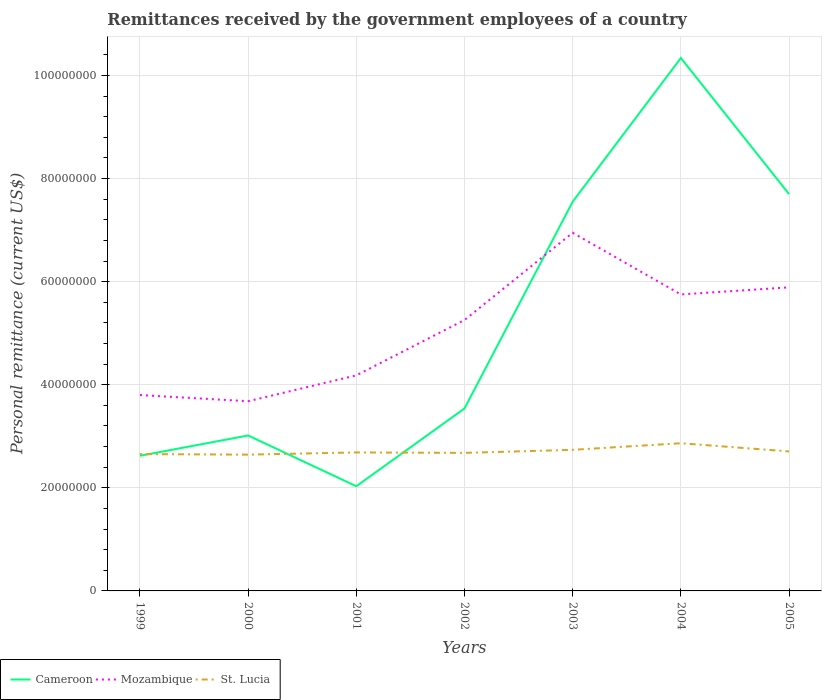How many different coloured lines are there?
Your response must be concise. 3. Across all years, what is the maximum remittances received by the government employees in St. Lucia?
Your answer should be very brief. 2.64e+07. In which year was the remittances received by the government employees in Mozambique maximum?
Your response must be concise. 2000. What is the total remittances received by the government employees in St. Lucia in the graph?
Your response must be concise. 1.04e+05. What is the difference between the highest and the second highest remittances received by the government employees in Cameroon?
Provide a succinct answer. 8.31e+07. Is the remittances received by the government employees in St. Lucia strictly greater than the remittances received by the government employees in Mozambique over the years?
Provide a short and direct response. Yes. How many lines are there?
Provide a short and direct response. 3. How many years are there in the graph?
Ensure brevity in your answer.  7. What is the difference between two consecutive major ticks on the Y-axis?
Provide a succinct answer. 2.00e+07. Are the values on the major ticks of Y-axis written in scientific E-notation?
Provide a short and direct response. No. How are the legend labels stacked?
Keep it short and to the point. Horizontal. What is the title of the graph?
Your answer should be compact. Remittances received by the government employees of a country. What is the label or title of the X-axis?
Make the answer very short. Years. What is the label or title of the Y-axis?
Provide a succinct answer. Personal remittance (current US$). What is the Personal remittance (current US$) of Cameroon in 1999?
Provide a succinct answer. 2.62e+07. What is the Personal remittance (current US$) of Mozambique in 1999?
Provide a short and direct response. 3.80e+07. What is the Personal remittance (current US$) of St. Lucia in 1999?
Provide a short and direct response. 2.65e+07. What is the Personal remittance (current US$) in Cameroon in 2000?
Provide a succinct answer. 3.02e+07. What is the Personal remittance (current US$) of Mozambique in 2000?
Your response must be concise. 3.68e+07. What is the Personal remittance (current US$) of St. Lucia in 2000?
Offer a terse response. 2.64e+07. What is the Personal remittance (current US$) of Cameroon in 2001?
Ensure brevity in your answer.  2.03e+07. What is the Personal remittance (current US$) of Mozambique in 2001?
Your answer should be very brief. 4.18e+07. What is the Personal remittance (current US$) in St. Lucia in 2001?
Keep it short and to the point. 2.69e+07. What is the Personal remittance (current US$) in Cameroon in 2002?
Your answer should be compact. 3.54e+07. What is the Personal remittance (current US$) of Mozambique in 2002?
Offer a terse response. 5.26e+07. What is the Personal remittance (current US$) in St. Lucia in 2002?
Your answer should be very brief. 2.68e+07. What is the Personal remittance (current US$) of Cameroon in 2003?
Give a very brief answer. 7.55e+07. What is the Personal remittance (current US$) of Mozambique in 2003?
Keep it short and to the point. 6.95e+07. What is the Personal remittance (current US$) in St. Lucia in 2003?
Keep it short and to the point. 2.74e+07. What is the Personal remittance (current US$) in Cameroon in 2004?
Offer a very short reply. 1.03e+08. What is the Personal remittance (current US$) in Mozambique in 2004?
Provide a short and direct response. 5.75e+07. What is the Personal remittance (current US$) of St. Lucia in 2004?
Your response must be concise. 2.87e+07. What is the Personal remittance (current US$) of Cameroon in 2005?
Keep it short and to the point. 7.70e+07. What is the Personal remittance (current US$) of Mozambique in 2005?
Provide a succinct answer. 5.89e+07. What is the Personal remittance (current US$) in St. Lucia in 2005?
Make the answer very short. 2.71e+07. Across all years, what is the maximum Personal remittance (current US$) in Cameroon?
Provide a short and direct response. 1.03e+08. Across all years, what is the maximum Personal remittance (current US$) of Mozambique?
Your response must be concise. 6.95e+07. Across all years, what is the maximum Personal remittance (current US$) of St. Lucia?
Your answer should be compact. 2.87e+07. Across all years, what is the minimum Personal remittance (current US$) of Cameroon?
Your response must be concise. 2.03e+07. Across all years, what is the minimum Personal remittance (current US$) of Mozambique?
Make the answer very short. 3.68e+07. Across all years, what is the minimum Personal remittance (current US$) in St. Lucia?
Provide a succinct answer. 2.64e+07. What is the total Personal remittance (current US$) in Cameroon in the graph?
Provide a succinct answer. 3.68e+08. What is the total Personal remittance (current US$) of Mozambique in the graph?
Provide a short and direct response. 3.55e+08. What is the total Personal remittance (current US$) of St. Lucia in the graph?
Keep it short and to the point. 1.90e+08. What is the difference between the Personal remittance (current US$) of Cameroon in 1999 and that in 2000?
Provide a short and direct response. -3.94e+06. What is the difference between the Personal remittance (current US$) of Mozambique in 1999 and that in 2000?
Your response must be concise. 1.20e+06. What is the difference between the Personal remittance (current US$) of St. Lucia in 1999 and that in 2000?
Give a very brief answer. 1.04e+05. What is the difference between the Personal remittance (current US$) in Cameroon in 1999 and that in 2001?
Offer a very short reply. 5.91e+06. What is the difference between the Personal remittance (current US$) of Mozambique in 1999 and that in 2001?
Provide a short and direct response. -3.82e+06. What is the difference between the Personal remittance (current US$) of St. Lucia in 1999 and that in 2001?
Provide a succinct answer. -3.23e+05. What is the difference between the Personal remittance (current US$) in Cameroon in 1999 and that in 2002?
Keep it short and to the point. -9.18e+06. What is the difference between the Personal remittance (current US$) of Mozambique in 1999 and that in 2002?
Ensure brevity in your answer.  -1.46e+07. What is the difference between the Personal remittance (current US$) of St. Lucia in 1999 and that in 2002?
Your answer should be compact. -2.34e+05. What is the difference between the Personal remittance (current US$) in Cameroon in 1999 and that in 2003?
Give a very brief answer. -4.93e+07. What is the difference between the Personal remittance (current US$) of Mozambique in 1999 and that in 2003?
Your response must be concise. -3.15e+07. What is the difference between the Personal remittance (current US$) of St. Lucia in 1999 and that in 2003?
Keep it short and to the point. -8.27e+05. What is the difference between the Personal remittance (current US$) in Cameroon in 1999 and that in 2004?
Keep it short and to the point. -7.72e+07. What is the difference between the Personal remittance (current US$) of Mozambique in 1999 and that in 2004?
Ensure brevity in your answer.  -1.95e+07. What is the difference between the Personal remittance (current US$) of St. Lucia in 1999 and that in 2004?
Your answer should be very brief. -2.11e+06. What is the difference between the Personal remittance (current US$) of Cameroon in 1999 and that in 2005?
Provide a succinct answer. -5.08e+07. What is the difference between the Personal remittance (current US$) of Mozambique in 1999 and that in 2005?
Your response must be concise. -2.09e+07. What is the difference between the Personal remittance (current US$) in St. Lucia in 1999 and that in 2005?
Your answer should be compact. -5.19e+05. What is the difference between the Personal remittance (current US$) of Cameroon in 2000 and that in 2001?
Your response must be concise. 9.85e+06. What is the difference between the Personal remittance (current US$) of Mozambique in 2000 and that in 2001?
Provide a succinct answer. -5.02e+06. What is the difference between the Personal remittance (current US$) of St. Lucia in 2000 and that in 2001?
Your response must be concise. -4.27e+05. What is the difference between the Personal remittance (current US$) of Cameroon in 2000 and that in 2002?
Ensure brevity in your answer.  -5.24e+06. What is the difference between the Personal remittance (current US$) in Mozambique in 2000 and that in 2002?
Give a very brief answer. -1.58e+07. What is the difference between the Personal remittance (current US$) in St. Lucia in 2000 and that in 2002?
Provide a succinct answer. -3.38e+05. What is the difference between the Personal remittance (current US$) in Cameroon in 2000 and that in 2003?
Ensure brevity in your answer.  -4.54e+07. What is the difference between the Personal remittance (current US$) of Mozambique in 2000 and that in 2003?
Your response must be concise. -3.27e+07. What is the difference between the Personal remittance (current US$) of St. Lucia in 2000 and that in 2003?
Give a very brief answer. -9.31e+05. What is the difference between the Personal remittance (current US$) of Cameroon in 2000 and that in 2004?
Your response must be concise. -7.32e+07. What is the difference between the Personal remittance (current US$) of Mozambique in 2000 and that in 2004?
Your response must be concise. -2.07e+07. What is the difference between the Personal remittance (current US$) of St. Lucia in 2000 and that in 2004?
Your response must be concise. -2.21e+06. What is the difference between the Personal remittance (current US$) of Cameroon in 2000 and that in 2005?
Provide a short and direct response. -4.68e+07. What is the difference between the Personal remittance (current US$) of Mozambique in 2000 and that in 2005?
Ensure brevity in your answer.  -2.21e+07. What is the difference between the Personal remittance (current US$) of St. Lucia in 2000 and that in 2005?
Your response must be concise. -6.23e+05. What is the difference between the Personal remittance (current US$) in Cameroon in 2001 and that in 2002?
Offer a very short reply. -1.51e+07. What is the difference between the Personal remittance (current US$) in Mozambique in 2001 and that in 2002?
Offer a terse response. -1.07e+07. What is the difference between the Personal remittance (current US$) of St. Lucia in 2001 and that in 2002?
Make the answer very short. 8.88e+04. What is the difference between the Personal remittance (current US$) of Cameroon in 2001 and that in 2003?
Provide a succinct answer. -5.52e+07. What is the difference between the Personal remittance (current US$) in Mozambique in 2001 and that in 2003?
Make the answer very short. -2.77e+07. What is the difference between the Personal remittance (current US$) of St. Lucia in 2001 and that in 2003?
Give a very brief answer. -5.04e+05. What is the difference between the Personal remittance (current US$) in Cameroon in 2001 and that in 2004?
Your answer should be compact. -8.31e+07. What is the difference between the Personal remittance (current US$) in Mozambique in 2001 and that in 2004?
Your answer should be very brief. -1.57e+07. What is the difference between the Personal remittance (current US$) of St. Lucia in 2001 and that in 2004?
Your response must be concise. -1.78e+06. What is the difference between the Personal remittance (current US$) in Cameroon in 2001 and that in 2005?
Your response must be concise. -5.67e+07. What is the difference between the Personal remittance (current US$) in Mozambique in 2001 and that in 2005?
Ensure brevity in your answer.  -1.71e+07. What is the difference between the Personal remittance (current US$) of St. Lucia in 2001 and that in 2005?
Offer a terse response. -1.96e+05. What is the difference between the Personal remittance (current US$) in Cameroon in 2002 and that in 2003?
Ensure brevity in your answer.  -4.01e+07. What is the difference between the Personal remittance (current US$) in Mozambique in 2002 and that in 2003?
Provide a succinct answer. -1.69e+07. What is the difference between the Personal remittance (current US$) in St. Lucia in 2002 and that in 2003?
Keep it short and to the point. -5.93e+05. What is the difference between the Personal remittance (current US$) in Cameroon in 2002 and that in 2004?
Ensure brevity in your answer.  -6.80e+07. What is the difference between the Personal remittance (current US$) in Mozambique in 2002 and that in 2004?
Your response must be concise. -4.96e+06. What is the difference between the Personal remittance (current US$) of St. Lucia in 2002 and that in 2004?
Your answer should be very brief. -1.87e+06. What is the difference between the Personal remittance (current US$) of Cameroon in 2002 and that in 2005?
Provide a short and direct response. -4.16e+07. What is the difference between the Personal remittance (current US$) in Mozambique in 2002 and that in 2005?
Your answer should be very brief. -6.34e+06. What is the difference between the Personal remittance (current US$) of St. Lucia in 2002 and that in 2005?
Offer a very short reply. -2.85e+05. What is the difference between the Personal remittance (current US$) in Cameroon in 2003 and that in 2004?
Make the answer very short. -2.79e+07. What is the difference between the Personal remittance (current US$) of Mozambique in 2003 and that in 2004?
Your response must be concise. 1.20e+07. What is the difference between the Personal remittance (current US$) in St. Lucia in 2003 and that in 2004?
Your response must be concise. -1.28e+06. What is the difference between the Personal remittance (current US$) in Cameroon in 2003 and that in 2005?
Keep it short and to the point. -1.48e+06. What is the difference between the Personal remittance (current US$) in Mozambique in 2003 and that in 2005?
Offer a terse response. 1.06e+07. What is the difference between the Personal remittance (current US$) of St. Lucia in 2003 and that in 2005?
Provide a succinct answer. 3.08e+05. What is the difference between the Personal remittance (current US$) of Cameroon in 2004 and that in 2005?
Your answer should be compact. 2.64e+07. What is the difference between the Personal remittance (current US$) of Mozambique in 2004 and that in 2005?
Provide a succinct answer. -1.37e+06. What is the difference between the Personal remittance (current US$) in St. Lucia in 2004 and that in 2005?
Provide a short and direct response. 1.59e+06. What is the difference between the Personal remittance (current US$) in Cameroon in 1999 and the Personal remittance (current US$) in Mozambique in 2000?
Your answer should be very brief. -1.06e+07. What is the difference between the Personal remittance (current US$) of Cameroon in 1999 and the Personal remittance (current US$) of St. Lucia in 2000?
Offer a very short reply. -2.19e+05. What is the difference between the Personal remittance (current US$) of Mozambique in 1999 and the Personal remittance (current US$) of St. Lucia in 2000?
Your answer should be compact. 1.16e+07. What is the difference between the Personal remittance (current US$) of Cameroon in 1999 and the Personal remittance (current US$) of Mozambique in 2001?
Provide a succinct answer. -1.56e+07. What is the difference between the Personal remittance (current US$) of Cameroon in 1999 and the Personal remittance (current US$) of St. Lucia in 2001?
Offer a terse response. -6.46e+05. What is the difference between the Personal remittance (current US$) in Mozambique in 1999 and the Personal remittance (current US$) in St. Lucia in 2001?
Keep it short and to the point. 1.11e+07. What is the difference between the Personal remittance (current US$) of Cameroon in 1999 and the Personal remittance (current US$) of Mozambique in 2002?
Offer a terse response. -2.63e+07. What is the difference between the Personal remittance (current US$) in Cameroon in 1999 and the Personal remittance (current US$) in St. Lucia in 2002?
Offer a very short reply. -5.57e+05. What is the difference between the Personal remittance (current US$) in Mozambique in 1999 and the Personal remittance (current US$) in St. Lucia in 2002?
Your response must be concise. 1.12e+07. What is the difference between the Personal remittance (current US$) in Cameroon in 1999 and the Personal remittance (current US$) in Mozambique in 2003?
Your answer should be compact. -4.33e+07. What is the difference between the Personal remittance (current US$) in Cameroon in 1999 and the Personal remittance (current US$) in St. Lucia in 2003?
Provide a short and direct response. -1.15e+06. What is the difference between the Personal remittance (current US$) of Mozambique in 1999 and the Personal remittance (current US$) of St. Lucia in 2003?
Offer a very short reply. 1.06e+07. What is the difference between the Personal remittance (current US$) of Cameroon in 1999 and the Personal remittance (current US$) of Mozambique in 2004?
Make the answer very short. -3.13e+07. What is the difference between the Personal remittance (current US$) of Cameroon in 1999 and the Personal remittance (current US$) of St. Lucia in 2004?
Provide a short and direct response. -2.43e+06. What is the difference between the Personal remittance (current US$) of Mozambique in 1999 and the Personal remittance (current US$) of St. Lucia in 2004?
Your answer should be compact. 9.35e+06. What is the difference between the Personal remittance (current US$) of Cameroon in 1999 and the Personal remittance (current US$) of Mozambique in 2005?
Give a very brief answer. -3.27e+07. What is the difference between the Personal remittance (current US$) in Cameroon in 1999 and the Personal remittance (current US$) in St. Lucia in 2005?
Make the answer very short. -8.42e+05. What is the difference between the Personal remittance (current US$) of Mozambique in 1999 and the Personal remittance (current US$) of St. Lucia in 2005?
Give a very brief answer. 1.09e+07. What is the difference between the Personal remittance (current US$) of Cameroon in 2000 and the Personal remittance (current US$) of Mozambique in 2001?
Make the answer very short. -1.17e+07. What is the difference between the Personal remittance (current US$) in Cameroon in 2000 and the Personal remittance (current US$) in St. Lucia in 2001?
Your answer should be compact. 3.29e+06. What is the difference between the Personal remittance (current US$) of Mozambique in 2000 and the Personal remittance (current US$) of St. Lucia in 2001?
Give a very brief answer. 9.93e+06. What is the difference between the Personal remittance (current US$) of Cameroon in 2000 and the Personal remittance (current US$) of Mozambique in 2002?
Provide a succinct answer. -2.24e+07. What is the difference between the Personal remittance (current US$) in Cameroon in 2000 and the Personal remittance (current US$) in St. Lucia in 2002?
Offer a terse response. 3.38e+06. What is the difference between the Personal remittance (current US$) of Mozambique in 2000 and the Personal remittance (current US$) of St. Lucia in 2002?
Provide a short and direct response. 1.00e+07. What is the difference between the Personal remittance (current US$) of Cameroon in 2000 and the Personal remittance (current US$) of Mozambique in 2003?
Provide a short and direct response. -3.93e+07. What is the difference between the Personal remittance (current US$) in Cameroon in 2000 and the Personal remittance (current US$) in St. Lucia in 2003?
Give a very brief answer. 2.79e+06. What is the difference between the Personal remittance (current US$) of Mozambique in 2000 and the Personal remittance (current US$) of St. Lucia in 2003?
Your answer should be very brief. 9.43e+06. What is the difference between the Personal remittance (current US$) of Cameroon in 2000 and the Personal remittance (current US$) of Mozambique in 2004?
Your response must be concise. -2.74e+07. What is the difference between the Personal remittance (current US$) in Cameroon in 2000 and the Personal remittance (current US$) in St. Lucia in 2004?
Keep it short and to the point. 1.51e+06. What is the difference between the Personal remittance (current US$) in Mozambique in 2000 and the Personal remittance (current US$) in St. Lucia in 2004?
Offer a very short reply. 8.15e+06. What is the difference between the Personal remittance (current US$) of Cameroon in 2000 and the Personal remittance (current US$) of Mozambique in 2005?
Offer a terse response. -2.87e+07. What is the difference between the Personal remittance (current US$) in Cameroon in 2000 and the Personal remittance (current US$) in St. Lucia in 2005?
Your answer should be compact. 3.10e+06. What is the difference between the Personal remittance (current US$) in Mozambique in 2000 and the Personal remittance (current US$) in St. Lucia in 2005?
Offer a very short reply. 9.74e+06. What is the difference between the Personal remittance (current US$) of Cameroon in 2001 and the Personal remittance (current US$) of Mozambique in 2002?
Your answer should be compact. -3.22e+07. What is the difference between the Personal remittance (current US$) of Cameroon in 2001 and the Personal remittance (current US$) of St. Lucia in 2002?
Your answer should be compact. -6.47e+06. What is the difference between the Personal remittance (current US$) of Mozambique in 2001 and the Personal remittance (current US$) of St. Lucia in 2002?
Make the answer very short. 1.50e+07. What is the difference between the Personal remittance (current US$) of Cameroon in 2001 and the Personal remittance (current US$) of Mozambique in 2003?
Make the answer very short. -4.92e+07. What is the difference between the Personal remittance (current US$) in Cameroon in 2001 and the Personal remittance (current US$) in St. Lucia in 2003?
Provide a succinct answer. -7.06e+06. What is the difference between the Personal remittance (current US$) in Mozambique in 2001 and the Personal remittance (current US$) in St. Lucia in 2003?
Your response must be concise. 1.44e+07. What is the difference between the Personal remittance (current US$) of Cameroon in 2001 and the Personal remittance (current US$) of Mozambique in 2004?
Keep it short and to the point. -3.72e+07. What is the difference between the Personal remittance (current US$) in Cameroon in 2001 and the Personal remittance (current US$) in St. Lucia in 2004?
Ensure brevity in your answer.  -8.34e+06. What is the difference between the Personal remittance (current US$) of Mozambique in 2001 and the Personal remittance (current US$) of St. Lucia in 2004?
Your answer should be very brief. 1.32e+07. What is the difference between the Personal remittance (current US$) of Cameroon in 2001 and the Personal remittance (current US$) of Mozambique in 2005?
Keep it short and to the point. -3.86e+07. What is the difference between the Personal remittance (current US$) of Cameroon in 2001 and the Personal remittance (current US$) of St. Lucia in 2005?
Offer a terse response. -6.75e+06. What is the difference between the Personal remittance (current US$) in Mozambique in 2001 and the Personal remittance (current US$) in St. Lucia in 2005?
Offer a terse response. 1.48e+07. What is the difference between the Personal remittance (current US$) of Cameroon in 2002 and the Personal remittance (current US$) of Mozambique in 2003?
Your answer should be compact. -3.41e+07. What is the difference between the Personal remittance (current US$) in Cameroon in 2002 and the Personal remittance (current US$) in St. Lucia in 2003?
Your response must be concise. 8.03e+06. What is the difference between the Personal remittance (current US$) of Mozambique in 2002 and the Personal remittance (current US$) of St. Lucia in 2003?
Offer a very short reply. 2.52e+07. What is the difference between the Personal remittance (current US$) of Cameroon in 2002 and the Personal remittance (current US$) of Mozambique in 2004?
Provide a short and direct response. -2.21e+07. What is the difference between the Personal remittance (current US$) in Cameroon in 2002 and the Personal remittance (current US$) in St. Lucia in 2004?
Offer a terse response. 6.75e+06. What is the difference between the Personal remittance (current US$) of Mozambique in 2002 and the Personal remittance (current US$) of St. Lucia in 2004?
Offer a very short reply. 2.39e+07. What is the difference between the Personal remittance (current US$) of Cameroon in 2002 and the Personal remittance (current US$) of Mozambique in 2005?
Provide a succinct answer. -2.35e+07. What is the difference between the Personal remittance (current US$) of Cameroon in 2002 and the Personal remittance (current US$) of St. Lucia in 2005?
Your response must be concise. 8.33e+06. What is the difference between the Personal remittance (current US$) of Mozambique in 2002 and the Personal remittance (current US$) of St. Lucia in 2005?
Your answer should be compact. 2.55e+07. What is the difference between the Personal remittance (current US$) of Cameroon in 2003 and the Personal remittance (current US$) of Mozambique in 2004?
Offer a very short reply. 1.80e+07. What is the difference between the Personal remittance (current US$) in Cameroon in 2003 and the Personal remittance (current US$) in St. Lucia in 2004?
Keep it short and to the point. 4.69e+07. What is the difference between the Personal remittance (current US$) in Mozambique in 2003 and the Personal remittance (current US$) in St. Lucia in 2004?
Your answer should be very brief. 4.08e+07. What is the difference between the Personal remittance (current US$) in Cameroon in 2003 and the Personal remittance (current US$) in Mozambique in 2005?
Offer a very short reply. 1.66e+07. What is the difference between the Personal remittance (current US$) of Cameroon in 2003 and the Personal remittance (current US$) of St. Lucia in 2005?
Keep it short and to the point. 4.84e+07. What is the difference between the Personal remittance (current US$) of Mozambique in 2003 and the Personal remittance (current US$) of St. Lucia in 2005?
Your response must be concise. 4.24e+07. What is the difference between the Personal remittance (current US$) in Cameroon in 2004 and the Personal remittance (current US$) in Mozambique in 2005?
Offer a very short reply. 4.45e+07. What is the difference between the Personal remittance (current US$) in Cameroon in 2004 and the Personal remittance (current US$) in St. Lucia in 2005?
Your answer should be very brief. 7.63e+07. What is the difference between the Personal remittance (current US$) of Mozambique in 2004 and the Personal remittance (current US$) of St. Lucia in 2005?
Provide a succinct answer. 3.05e+07. What is the average Personal remittance (current US$) in Cameroon per year?
Provide a short and direct response. 5.26e+07. What is the average Personal remittance (current US$) in Mozambique per year?
Your response must be concise. 5.07e+07. What is the average Personal remittance (current US$) of St. Lucia per year?
Keep it short and to the point. 2.71e+07. In the year 1999, what is the difference between the Personal remittance (current US$) in Cameroon and Personal remittance (current US$) in Mozambique?
Provide a short and direct response. -1.18e+07. In the year 1999, what is the difference between the Personal remittance (current US$) in Cameroon and Personal remittance (current US$) in St. Lucia?
Provide a succinct answer. -3.23e+05. In the year 1999, what is the difference between the Personal remittance (current US$) in Mozambique and Personal remittance (current US$) in St. Lucia?
Ensure brevity in your answer.  1.15e+07. In the year 2000, what is the difference between the Personal remittance (current US$) of Cameroon and Personal remittance (current US$) of Mozambique?
Provide a succinct answer. -6.64e+06. In the year 2000, what is the difference between the Personal remittance (current US$) of Cameroon and Personal remittance (current US$) of St. Lucia?
Keep it short and to the point. 3.72e+06. In the year 2000, what is the difference between the Personal remittance (current US$) of Mozambique and Personal remittance (current US$) of St. Lucia?
Provide a succinct answer. 1.04e+07. In the year 2001, what is the difference between the Personal remittance (current US$) of Cameroon and Personal remittance (current US$) of Mozambique?
Your answer should be compact. -2.15e+07. In the year 2001, what is the difference between the Personal remittance (current US$) of Cameroon and Personal remittance (current US$) of St. Lucia?
Provide a succinct answer. -6.56e+06. In the year 2001, what is the difference between the Personal remittance (current US$) of Mozambique and Personal remittance (current US$) of St. Lucia?
Keep it short and to the point. 1.49e+07. In the year 2002, what is the difference between the Personal remittance (current US$) of Cameroon and Personal remittance (current US$) of Mozambique?
Offer a terse response. -1.72e+07. In the year 2002, what is the difference between the Personal remittance (current US$) in Cameroon and Personal remittance (current US$) in St. Lucia?
Your answer should be compact. 8.62e+06. In the year 2002, what is the difference between the Personal remittance (current US$) of Mozambique and Personal remittance (current US$) of St. Lucia?
Your answer should be compact. 2.58e+07. In the year 2003, what is the difference between the Personal remittance (current US$) in Cameroon and Personal remittance (current US$) in Mozambique?
Give a very brief answer. 6.03e+06. In the year 2003, what is the difference between the Personal remittance (current US$) of Cameroon and Personal remittance (current US$) of St. Lucia?
Make the answer very short. 4.81e+07. In the year 2003, what is the difference between the Personal remittance (current US$) of Mozambique and Personal remittance (current US$) of St. Lucia?
Make the answer very short. 4.21e+07. In the year 2004, what is the difference between the Personal remittance (current US$) in Cameroon and Personal remittance (current US$) in Mozambique?
Provide a succinct answer. 4.59e+07. In the year 2004, what is the difference between the Personal remittance (current US$) of Cameroon and Personal remittance (current US$) of St. Lucia?
Your answer should be very brief. 7.47e+07. In the year 2004, what is the difference between the Personal remittance (current US$) of Mozambique and Personal remittance (current US$) of St. Lucia?
Keep it short and to the point. 2.89e+07. In the year 2005, what is the difference between the Personal remittance (current US$) of Cameroon and Personal remittance (current US$) of Mozambique?
Provide a succinct answer. 1.81e+07. In the year 2005, what is the difference between the Personal remittance (current US$) in Cameroon and Personal remittance (current US$) in St. Lucia?
Provide a succinct answer. 4.99e+07. In the year 2005, what is the difference between the Personal remittance (current US$) in Mozambique and Personal remittance (current US$) in St. Lucia?
Ensure brevity in your answer.  3.18e+07. What is the ratio of the Personal remittance (current US$) in Cameroon in 1999 to that in 2000?
Give a very brief answer. 0.87. What is the ratio of the Personal remittance (current US$) of Mozambique in 1999 to that in 2000?
Keep it short and to the point. 1.03. What is the ratio of the Personal remittance (current US$) of St. Lucia in 1999 to that in 2000?
Your answer should be compact. 1. What is the ratio of the Personal remittance (current US$) in Cameroon in 1999 to that in 2001?
Make the answer very short. 1.29. What is the ratio of the Personal remittance (current US$) in Mozambique in 1999 to that in 2001?
Provide a succinct answer. 0.91. What is the ratio of the Personal remittance (current US$) of Cameroon in 1999 to that in 2002?
Keep it short and to the point. 0.74. What is the ratio of the Personal remittance (current US$) in Mozambique in 1999 to that in 2002?
Offer a very short reply. 0.72. What is the ratio of the Personal remittance (current US$) in Cameroon in 1999 to that in 2003?
Your response must be concise. 0.35. What is the ratio of the Personal remittance (current US$) of Mozambique in 1999 to that in 2003?
Offer a terse response. 0.55. What is the ratio of the Personal remittance (current US$) of St. Lucia in 1999 to that in 2003?
Offer a terse response. 0.97. What is the ratio of the Personal remittance (current US$) in Cameroon in 1999 to that in 2004?
Ensure brevity in your answer.  0.25. What is the ratio of the Personal remittance (current US$) of Mozambique in 1999 to that in 2004?
Your answer should be very brief. 0.66. What is the ratio of the Personal remittance (current US$) of St. Lucia in 1999 to that in 2004?
Provide a succinct answer. 0.93. What is the ratio of the Personal remittance (current US$) of Cameroon in 1999 to that in 2005?
Your response must be concise. 0.34. What is the ratio of the Personal remittance (current US$) in Mozambique in 1999 to that in 2005?
Offer a very short reply. 0.65. What is the ratio of the Personal remittance (current US$) in St. Lucia in 1999 to that in 2005?
Keep it short and to the point. 0.98. What is the ratio of the Personal remittance (current US$) in Cameroon in 2000 to that in 2001?
Keep it short and to the point. 1.48. What is the ratio of the Personal remittance (current US$) of Mozambique in 2000 to that in 2001?
Offer a very short reply. 0.88. What is the ratio of the Personal remittance (current US$) of St. Lucia in 2000 to that in 2001?
Keep it short and to the point. 0.98. What is the ratio of the Personal remittance (current US$) in Cameroon in 2000 to that in 2002?
Give a very brief answer. 0.85. What is the ratio of the Personal remittance (current US$) of Mozambique in 2000 to that in 2002?
Ensure brevity in your answer.  0.7. What is the ratio of the Personal remittance (current US$) of St. Lucia in 2000 to that in 2002?
Your answer should be compact. 0.99. What is the ratio of the Personal remittance (current US$) of Cameroon in 2000 to that in 2003?
Ensure brevity in your answer.  0.4. What is the ratio of the Personal remittance (current US$) in Mozambique in 2000 to that in 2003?
Provide a succinct answer. 0.53. What is the ratio of the Personal remittance (current US$) of Cameroon in 2000 to that in 2004?
Make the answer very short. 0.29. What is the ratio of the Personal remittance (current US$) of Mozambique in 2000 to that in 2004?
Provide a succinct answer. 0.64. What is the ratio of the Personal remittance (current US$) in St. Lucia in 2000 to that in 2004?
Your answer should be very brief. 0.92. What is the ratio of the Personal remittance (current US$) of Cameroon in 2000 to that in 2005?
Provide a short and direct response. 0.39. What is the ratio of the Personal remittance (current US$) in Mozambique in 2000 to that in 2005?
Your answer should be very brief. 0.62. What is the ratio of the Personal remittance (current US$) of St. Lucia in 2000 to that in 2005?
Keep it short and to the point. 0.98. What is the ratio of the Personal remittance (current US$) of Cameroon in 2001 to that in 2002?
Your answer should be very brief. 0.57. What is the ratio of the Personal remittance (current US$) in Mozambique in 2001 to that in 2002?
Your response must be concise. 0.8. What is the ratio of the Personal remittance (current US$) in St. Lucia in 2001 to that in 2002?
Give a very brief answer. 1. What is the ratio of the Personal remittance (current US$) of Cameroon in 2001 to that in 2003?
Ensure brevity in your answer.  0.27. What is the ratio of the Personal remittance (current US$) of Mozambique in 2001 to that in 2003?
Your answer should be very brief. 0.6. What is the ratio of the Personal remittance (current US$) in St. Lucia in 2001 to that in 2003?
Offer a very short reply. 0.98. What is the ratio of the Personal remittance (current US$) in Cameroon in 2001 to that in 2004?
Offer a terse response. 0.2. What is the ratio of the Personal remittance (current US$) in Mozambique in 2001 to that in 2004?
Keep it short and to the point. 0.73. What is the ratio of the Personal remittance (current US$) of St. Lucia in 2001 to that in 2004?
Your answer should be very brief. 0.94. What is the ratio of the Personal remittance (current US$) in Cameroon in 2001 to that in 2005?
Provide a succinct answer. 0.26. What is the ratio of the Personal remittance (current US$) of Mozambique in 2001 to that in 2005?
Your response must be concise. 0.71. What is the ratio of the Personal remittance (current US$) in Cameroon in 2002 to that in 2003?
Provide a short and direct response. 0.47. What is the ratio of the Personal remittance (current US$) of Mozambique in 2002 to that in 2003?
Give a very brief answer. 0.76. What is the ratio of the Personal remittance (current US$) in St. Lucia in 2002 to that in 2003?
Your response must be concise. 0.98. What is the ratio of the Personal remittance (current US$) of Cameroon in 2002 to that in 2004?
Give a very brief answer. 0.34. What is the ratio of the Personal remittance (current US$) in Mozambique in 2002 to that in 2004?
Provide a short and direct response. 0.91. What is the ratio of the Personal remittance (current US$) of St. Lucia in 2002 to that in 2004?
Provide a succinct answer. 0.93. What is the ratio of the Personal remittance (current US$) in Cameroon in 2002 to that in 2005?
Offer a terse response. 0.46. What is the ratio of the Personal remittance (current US$) of Mozambique in 2002 to that in 2005?
Provide a succinct answer. 0.89. What is the ratio of the Personal remittance (current US$) in Cameroon in 2003 to that in 2004?
Provide a succinct answer. 0.73. What is the ratio of the Personal remittance (current US$) of Mozambique in 2003 to that in 2004?
Provide a short and direct response. 1.21. What is the ratio of the Personal remittance (current US$) in St. Lucia in 2003 to that in 2004?
Ensure brevity in your answer.  0.96. What is the ratio of the Personal remittance (current US$) of Cameroon in 2003 to that in 2005?
Your response must be concise. 0.98. What is the ratio of the Personal remittance (current US$) of Mozambique in 2003 to that in 2005?
Offer a terse response. 1.18. What is the ratio of the Personal remittance (current US$) in St. Lucia in 2003 to that in 2005?
Give a very brief answer. 1.01. What is the ratio of the Personal remittance (current US$) of Cameroon in 2004 to that in 2005?
Make the answer very short. 1.34. What is the ratio of the Personal remittance (current US$) of Mozambique in 2004 to that in 2005?
Your answer should be compact. 0.98. What is the ratio of the Personal remittance (current US$) of St. Lucia in 2004 to that in 2005?
Provide a succinct answer. 1.06. What is the difference between the highest and the second highest Personal remittance (current US$) in Cameroon?
Your answer should be compact. 2.64e+07. What is the difference between the highest and the second highest Personal remittance (current US$) in Mozambique?
Offer a very short reply. 1.06e+07. What is the difference between the highest and the second highest Personal remittance (current US$) in St. Lucia?
Provide a short and direct response. 1.28e+06. What is the difference between the highest and the lowest Personal remittance (current US$) of Cameroon?
Provide a short and direct response. 8.31e+07. What is the difference between the highest and the lowest Personal remittance (current US$) in Mozambique?
Provide a short and direct response. 3.27e+07. What is the difference between the highest and the lowest Personal remittance (current US$) of St. Lucia?
Offer a terse response. 2.21e+06. 